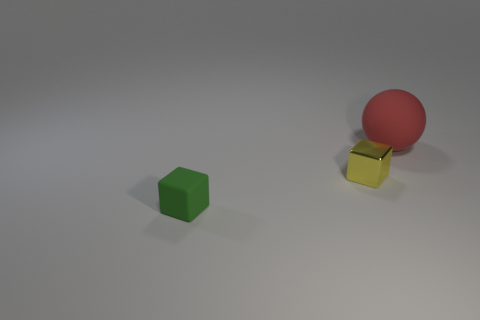What is the shape of the shiny thing that is the same size as the green rubber block?
Your answer should be very brief. Cube. There is a rubber thing behind the cube that is on the right side of the matte object that is in front of the large rubber sphere; what color is it?
Your answer should be very brief. Red. What number of objects are either things to the left of the large matte thing or tiny purple objects?
Make the answer very short. 2. What material is the green thing that is the same size as the yellow metallic object?
Provide a short and direct response. Rubber. There is a tiny thing behind the rubber object that is in front of the matte object on the right side of the small metal cube; what is its material?
Ensure brevity in your answer.  Metal. What is the color of the rubber cube?
Make the answer very short. Green. How many large objects are either red rubber objects or blue rubber cylinders?
Your response must be concise. 1. Are the object behind the tiny yellow thing and the small object behind the tiny rubber cube made of the same material?
Provide a short and direct response. No. Are there any big purple rubber balls?
Offer a very short reply. No. Are there more red matte objects that are left of the large object than matte objects that are to the left of the tiny yellow metallic thing?
Your response must be concise. No. 